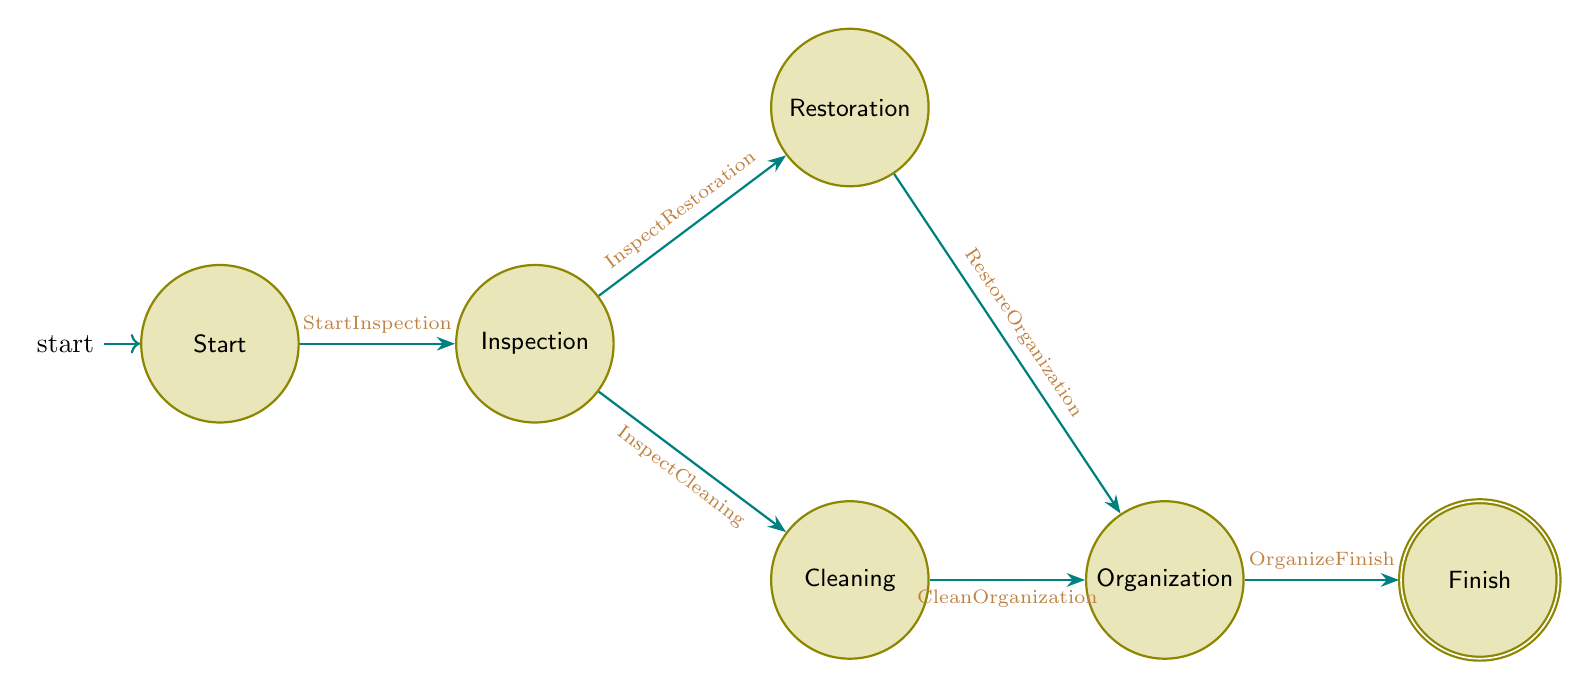What is the initial state in the diagram? The diagram starts with a state labeled "Start," which is indicated as the initial state before any maintenance begins.
Answer: Start How many states are present in the diagram? The diagram shows a total of six states: Start, Inspection, Cleaning, Restoration, Organization, and Finish.
Answer: 6 What transition leads from Inspection to Cleaning? The transition named "InspectCleaning" connects the state "Inspection" to the state "Cleaning" based on the process indicated.
Answer: InspectCleaning What is the last state in the routine? The final state after completing the entire maintenance routine is labeled "Finish."
Answer: Finish Which states can be reached directly from the Inspection state? From the Inspection state, one can directly reach both the Cleaning and Restoration states based on findings during the inspection.
Answer: Cleaning, Restoration If minor damages are found during Inspection, which state is reached next? If there are minor damages found, the transition from Inspection to Restoration occurs, leading to the Restoration state.
Answer: Restoration Which transition occurs after the Cleaning state? After the Cleaning state, the transition that occurs is "CleanOrganization," which leads to the Organization state.
Answer: CleanOrganization How many transitions are there in total? The diagram includes a total of six transitions: StartInspection, InspectCleaning, InspectRestoration, CleanOrganization, RestoreOrganization, and OrganizeFinish.
Answer: 6 What is the purpose of the Organization state? The Organization state is meant for reorganizing the collection and updating records after either Cleaning or Restoration.
Answer: Reorganizing and updating records 